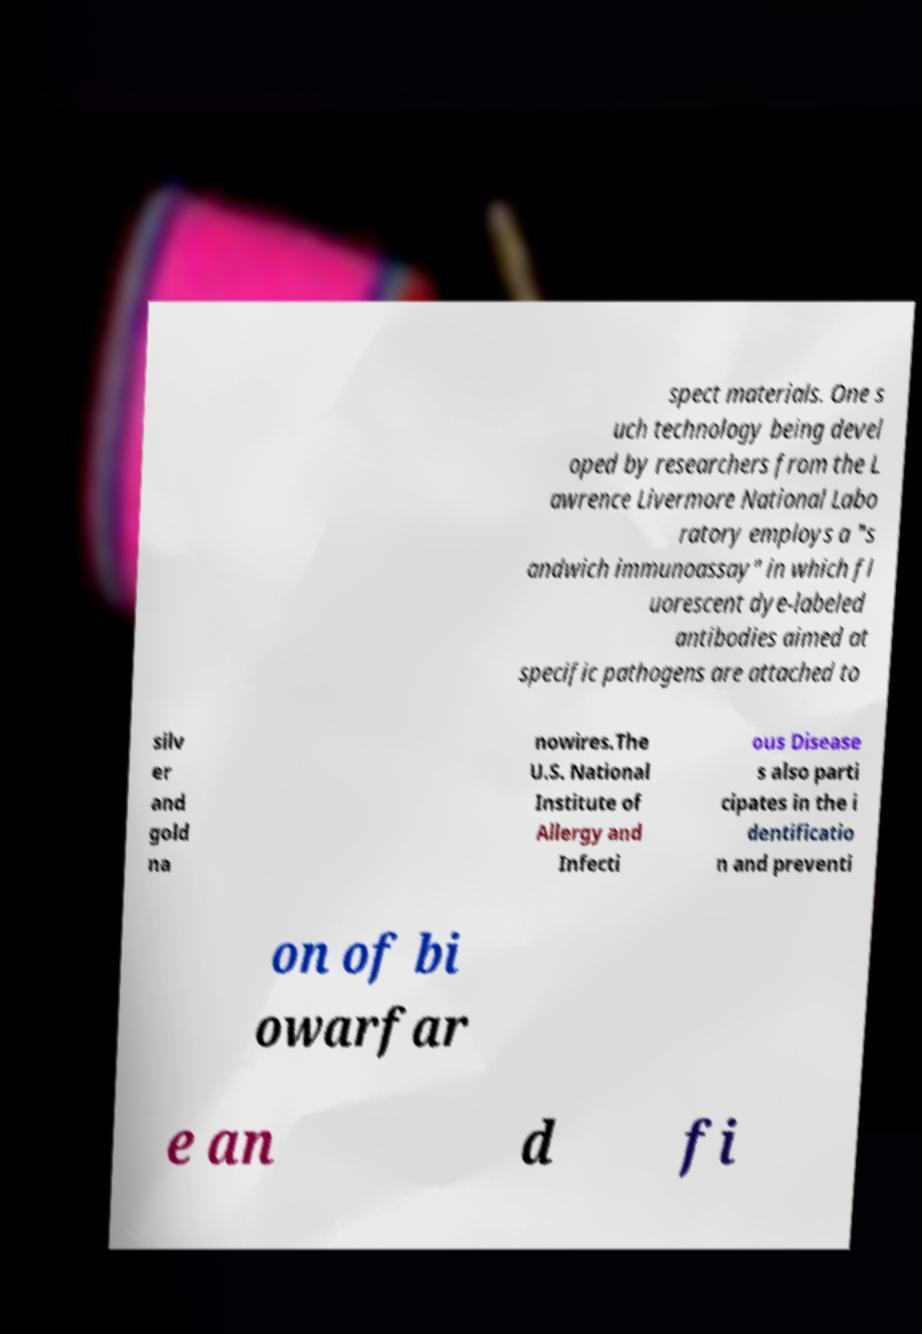Can you accurately transcribe the text from the provided image for me? spect materials. One s uch technology being devel oped by researchers from the L awrence Livermore National Labo ratory employs a "s andwich immunoassay" in which fl uorescent dye-labeled antibodies aimed at specific pathogens are attached to silv er and gold na nowires.The U.S. National Institute of Allergy and Infecti ous Disease s also parti cipates in the i dentificatio n and preventi on of bi owarfar e an d fi 